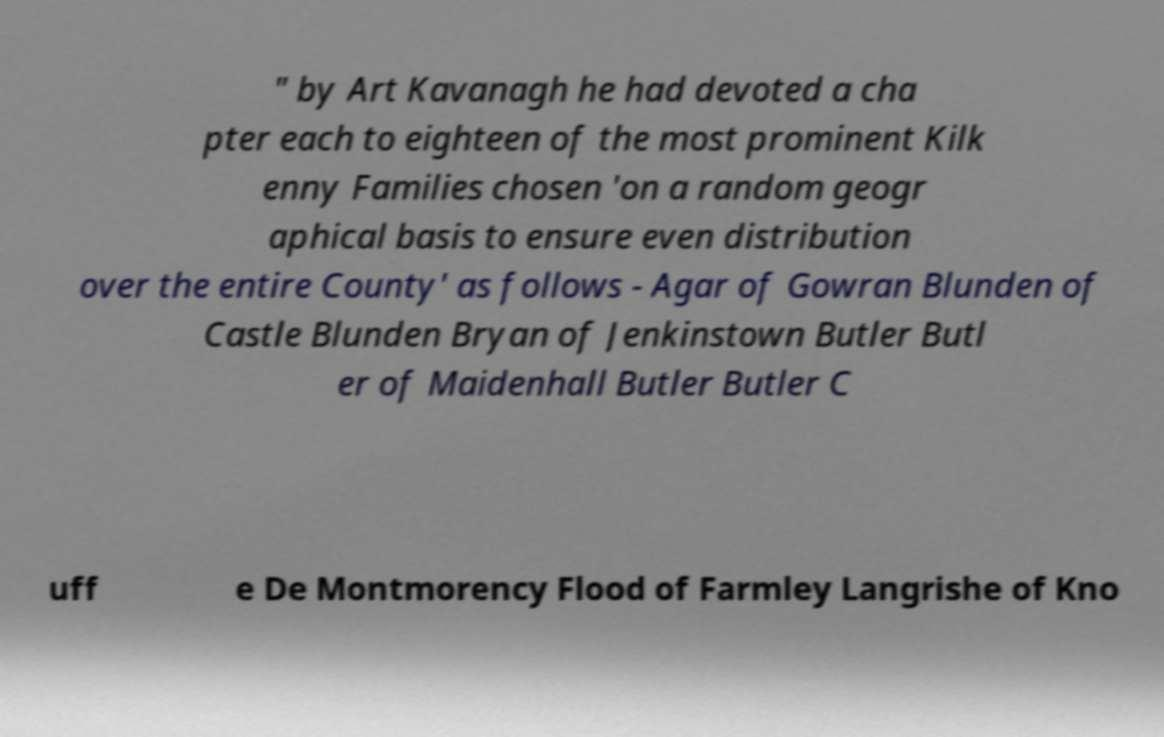Please read and relay the text visible in this image. What does it say? " by Art Kavanagh he had devoted a cha pter each to eighteen of the most prominent Kilk enny Families chosen 'on a random geogr aphical basis to ensure even distribution over the entire County' as follows - Agar of Gowran Blunden of Castle Blunden Bryan of Jenkinstown Butler Butl er of Maidenhall Butler Butler C uff e De Montmorency Flood of Farmley Langrishe of Kno 